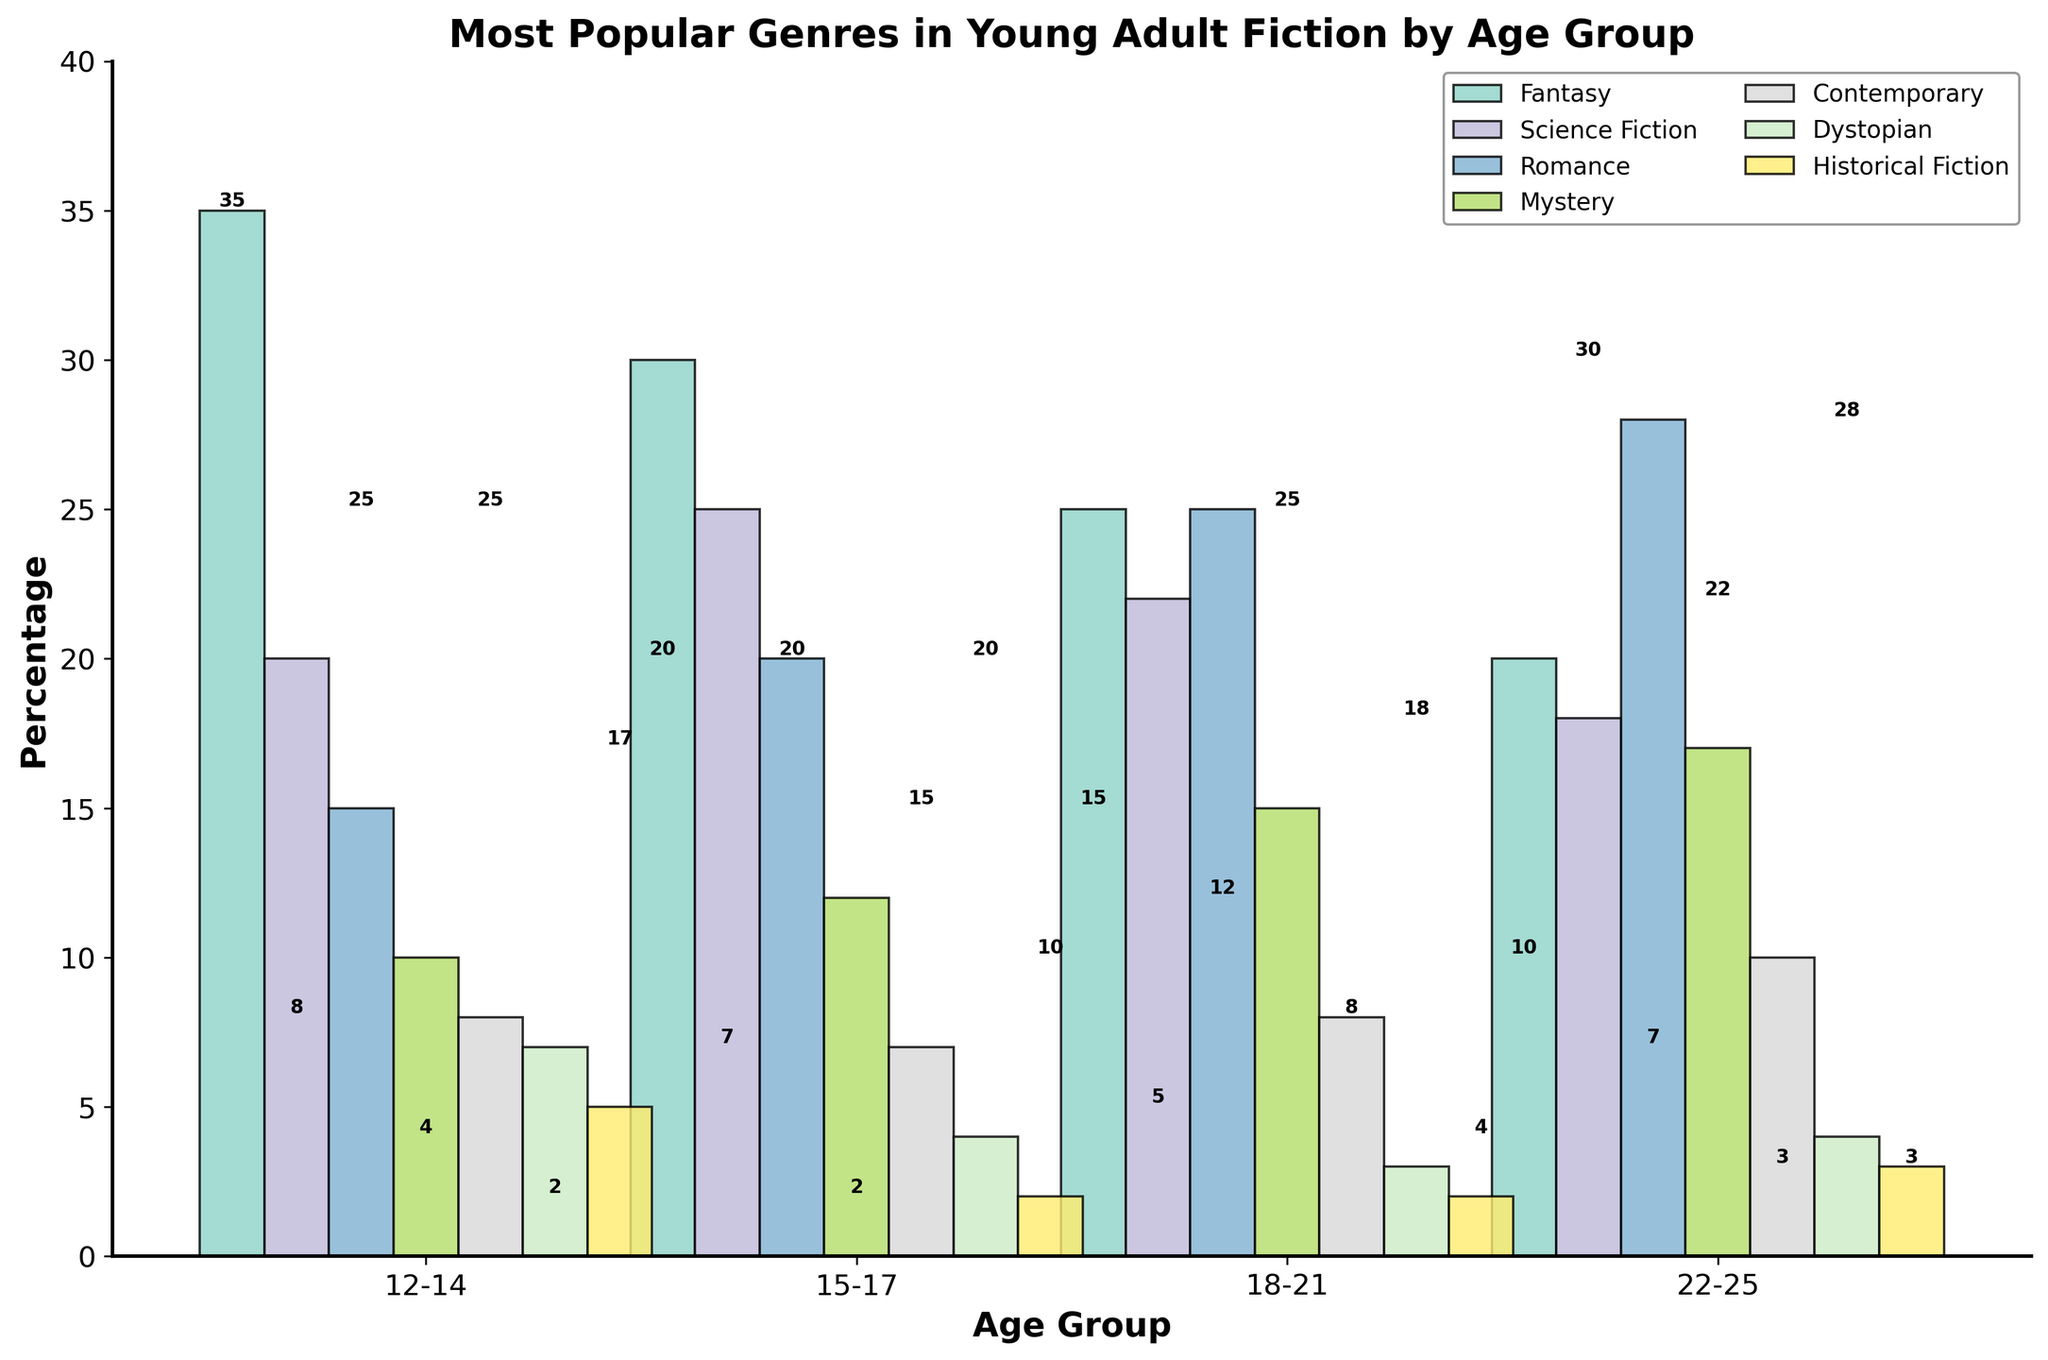What is the most popular genre among the 12-14 age group? By visually observing the heights of the bars for the 12-14 age group, we see that the Fantasy genre has the highest bar at 35%.
Answer: Fantasy Which age group prefers Romance the most? By comparing the heights of the Romance bars across all age groups, the 22-25 age group has the tallest bar at 28%.
Answer: 22-25 How does the popularity of Science Fiction differ between the 15-17 and 22-25 age groups? The bar for Science Fiction in the 15-17 age group is at 25%, while in the 22-25 age group it is at 18%. The difference is 25% - 18% = 7%.
Answer: 7% What is the combined percentage of Mystery and Contemporary genres for the 18-21 age group? The bar for Mystery is at 15% and for Contemporary it is at 8%. Adding these, 15% + 8% = 23%.
Answer: 23% Which two genres are equally popular in the 22-25 age group? By comparing the heights of the bars in the 22-25 age group, we see that Historical Fiction and Science Fiction bars are both at 3%.
Answer: Historical Fiction, Science Fiction In the 15-17 age group, which genre is more popular: Science Fiction or Romance? By comparing the heights of the bars for the 15-17 age group, the Science Fiction bar is at 25% while the Romance bar is at 20%, indicating Science Fiction is more popular.
Answer: Science Fiction What is the difference in the popularity of Fantasy between the 12-14 and 18-21 age groups? The Fantasy bar for the 12-14 age group is at 35%, and for the 18-21 age group it is at 25%. The difference is 35% - 25% = 10%.
Answer: 10% What is the least popular genre in the 15-17 age group? Among all the bars in the 15-17 age group, Historical Fiction has the lowest bar at 2%.
Answer: Historical Fiction How many genres have more than 20% popularity in the 15-17 age group? By observing the bars for the 15-17 age group, Fantasy (30%), Science Fiction (25%), and Romance (20%) have more than 20% popularity. The count is 3.
Answer: 3 Which genre has the least variation in popularity across all age groups? By examining the height of the bars across all age groups, Historical Fiction shows the least variation with consistently low values (5%, 2%, 2%, 3%).
Answer: Historical Fiction 